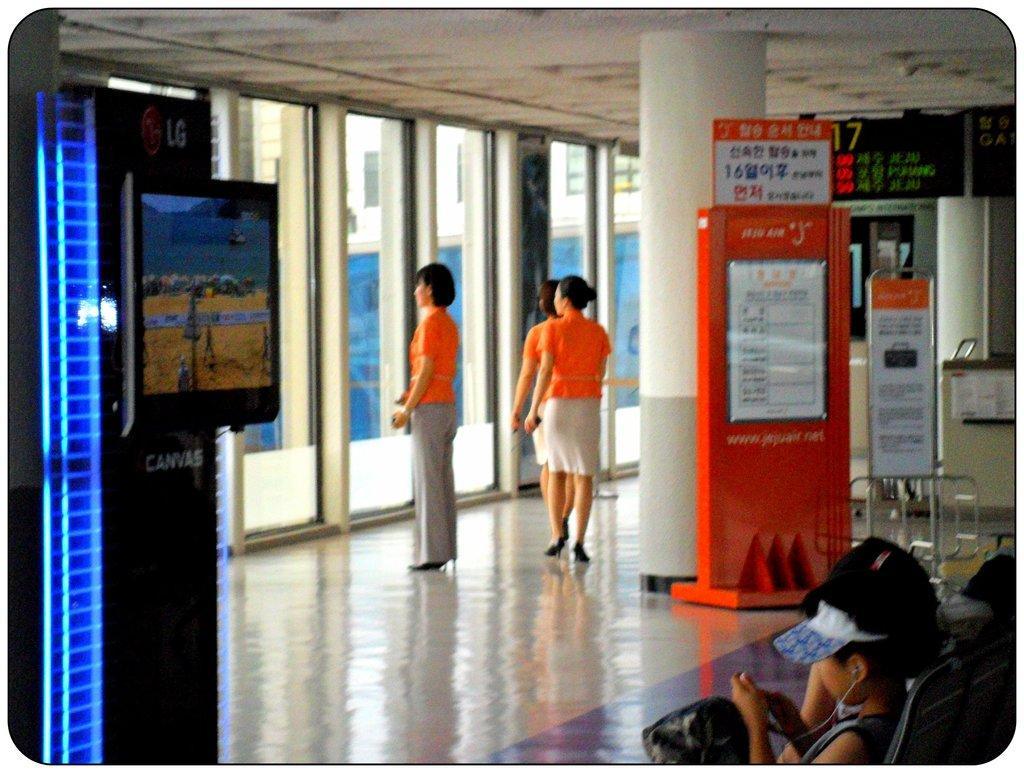Please provide a concise description of this image. In this picture we can see three women standing on the floor. In front of the women, there are glass windows. Through the windows, we can see a building. Behind the women, there is a pillar, board and some objects. At the bottom of the image, there are people sitting. On the left side of the image, there is a television attached to an object. At the top of the image, there is a ceiling. 